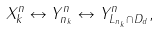Convert formula to latex. <formula><loc_0><loc_0><loc_500><loc_500>X _ { k } ^ { n } \leftrightarrow Y _ { n _ { k } } ^ { n } \leftrightarrow Y _ { L _ { n _ { k } } \cap D _ { d } } ^ { n } ,</formula> 